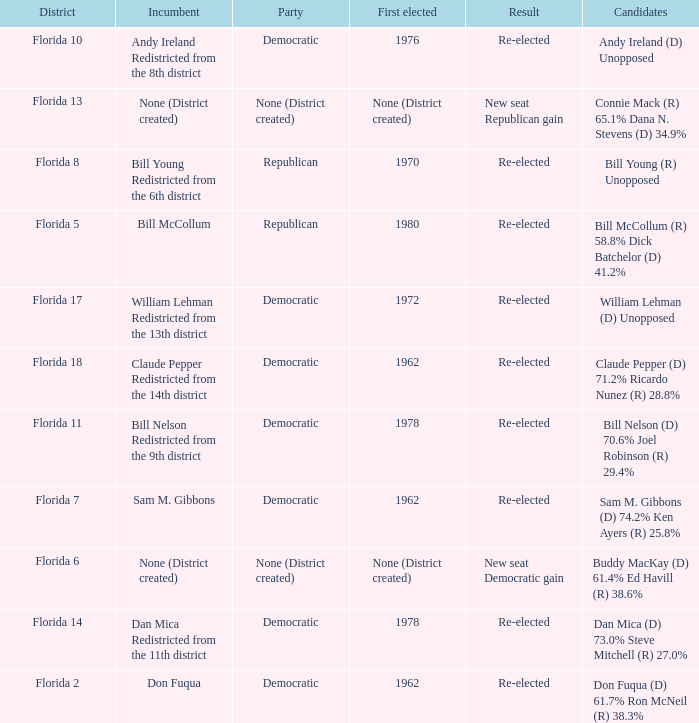Who is the the candidates with incumbent being don fuqua Don Fuqua (D) 61.7% Ron McNeil (R) 38.3%. 